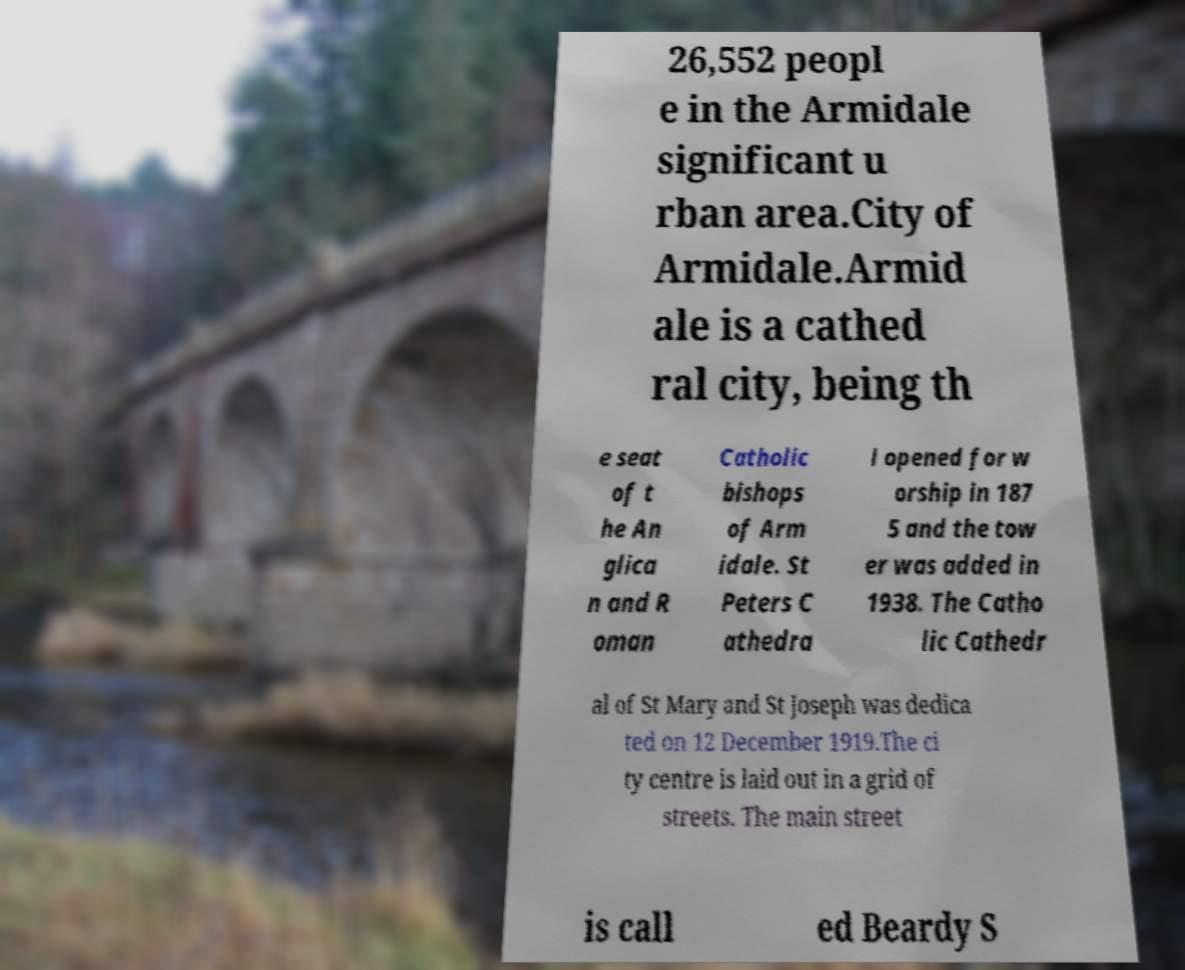For documentation purposes, I need the text within this image transcribed. Could you provide that? 26,552 peopl e in the Armidale significant u rban area.City of Armidale.Armid ale is a cathed ral city, being th e seat of t he An glica n and R oman Catholic bishops of Arm idale. St Peters C athedra l opened for w orship in 187 5 and the tow er was added in 1938. The Catho lic Cathedr al of St Mary and St Joseph was dedica ted on 12 December 1919.The ci ty centre is laid out in a grid of streets. The main street is call ed Beardy S 